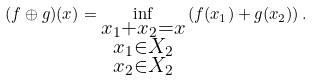<formula> <loc_0><loc_0><loc_500><loc_500>( f \oplus g ) ( x ) = \inf _ { \substack { x _ { 1 } + x _ { 2 } = x \\ x _ { 1 } \in X _ { 2 } \\ x _ { 2 } \in X _ { 2 } } } \left ( f ( x _ { 1 } ) + g ( x _ { 2 } ) \right ) .</formula> 